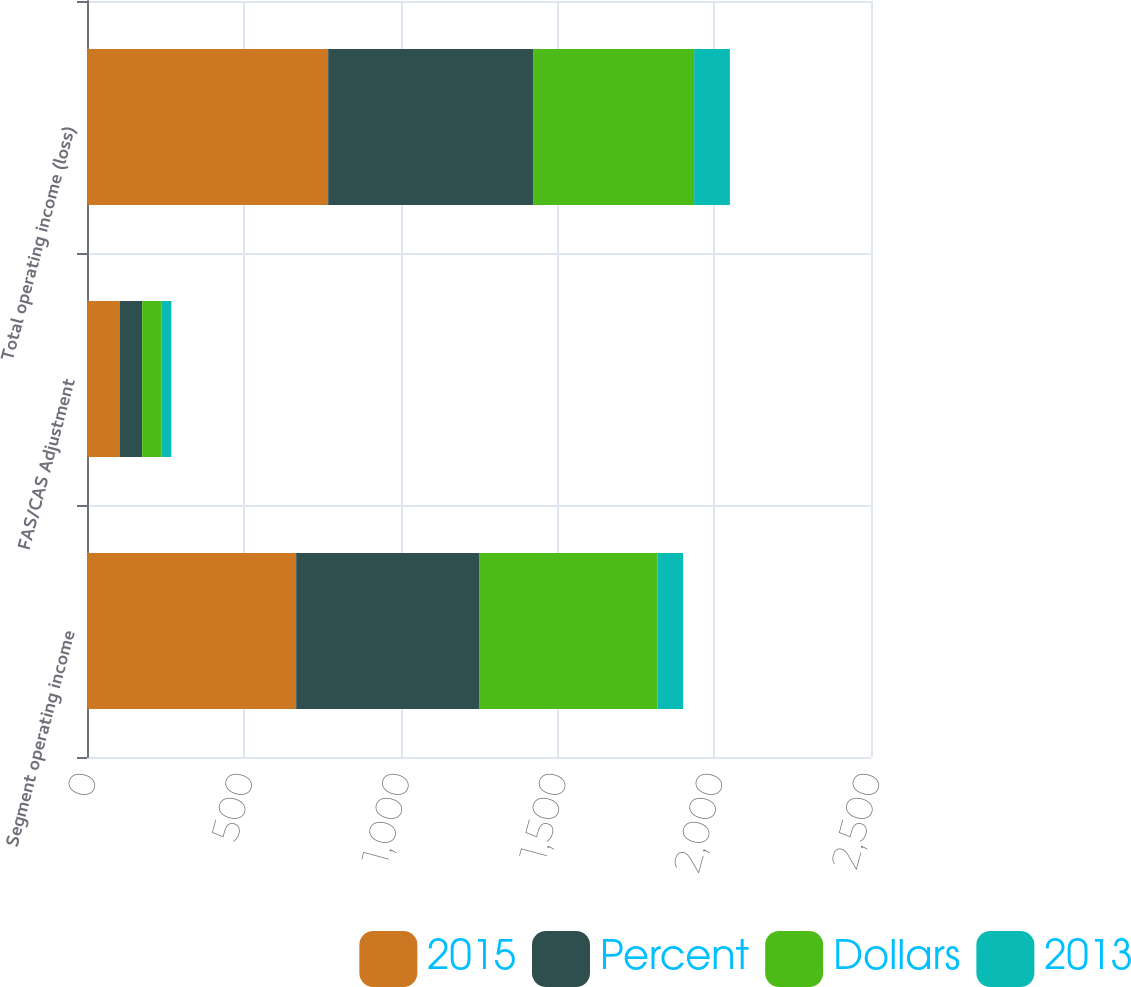Convert chart to OTSL. <chart><loc_0><loc_0><loc_500><loc_500><stacked_bar_chart><ecel><fcel>Segment operating income<fcel>FAS/CAS Adjustment<fcel>Total operating income (loss)<nl><fcel>2015<fcel>667<fcel>104<fcel>769<nl><fcel>Percent<fcel>585<fcel>72<fcel>655<nl><fcel>Dollars<fcel>567<fcel>61<fcel>512<nl><fcel>2013<fcel>82<fcel>32<fcel>114<nl></chart> 